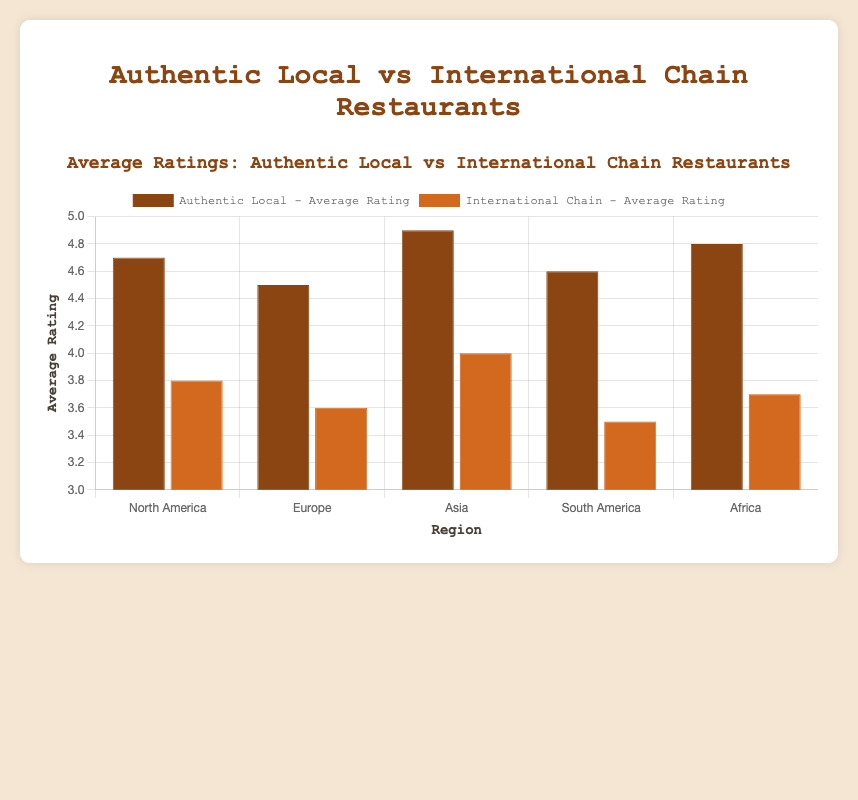Which type of restaurant has the highest average rating in Asia? Looking at the bars for Asia, Din Tai Fung (Authentic Local) has a rating of 4.9, while Starbucks (International Chain) has a rating of 4.0. Therefore, the highest average rating in Asia belongs to Din Tai Fung.
Answer: Authentic Local Between North America and Europe, which region has a higher average rating for International Chain restaurants? Compare the average ratings of International Chain restaurants in North America and Europe. McDonald's in North America has a rating of 3.8, whereas KFC in Europe has a rating of 3.6. Thus, North America has the higher average rating for International Chain restaurants.
Answer: North America What is the range of average ratings for Authentic Local restaurants across all regions? Identify the minimum and maximum average ratings for Authentic Local restaurants. The lowest rating is 4.5 (Europe) and the highest is 4.9 (Asia). Therefore, the range is 4.9 - 4.5 = 0.4.
Answer: 0.4 Which region has the largest difference in average ratings between Authentic Local and International Chain restaurants? Compute the difference in ratings between Authentic Local and International Chain restaurants for each region. North America: 4.7 - 3.8 = 0.9, Europe: 4.5 - 3.6 = 0.9, Asia: 4.9 - 4.0 = 0.9, South America: 4.6 - 3.5 = 1.1, Africa: 4.8 - 3.7 = 1.1. South America and Africa both have the largest difference of 1.1.
Answer: South America, Africa In which region do International Chain restaurants perform the best in terms of average rating? Compare the average ratings of International Chain restaurants across all regions. Starbucks in Asia has a rating of 4.0, which is the highest among International Chain restaurants. Therefore, the best performing region is Asia.
Answer: Asia How does the ambience score of Joe's Kansas City Bar-B-Que compare to McDonald's? Joe's Kansas City Bar-B-Que (Authentic Local in North America) has an ambience score of 8.9, while McDonald's (International Chain in North America) has an ambience score of 6.5. Joe's Kansas City Bar-B-Que has a higher ambience score than McDonald's.
Answer: Joe's Kansas City Bar-B-Que has a higher score What is the combined customer review count for Authentic Local restaurants in Europe and South America? Sum the customer review counts for Authentic Local restaurants in Europe and South America. Europe (Chez Maurice): 860, South America (Caminito Tango): 740. Therefore, the combined count is 860 + 740 = 1600.
Answer: 1600 Which restaurant in Africa has the lower average rating, and by how much is it lower than the higher-rated restaurant? Compare the average ratings of the two restaurants in Africa. Mamma B's Kitchen (Authentic Local) has a rating of 4.8, while Pizza Hut (International Chain) has a rating of 3.7. Pizza Hut has the lower rating by 4.8 - 3.7 = 1.1.
Answer: Pizza Hut, by 1.1 How does the price range of the highest-rated restaurant in South America compare to the price range of the highest-rated restaurant in Africa? Identify the highest-rated restaurant in South America (Caminito Tango, 4.6) and Africa (Mamma B's Kitchen, 4.8). Caminito Tango has a price range of $$, while Mamma B's Kitchen has a price range of $. Therefore, Caminito Tango has a higher price range.
Answer: Caminito Tango has a higher price range 